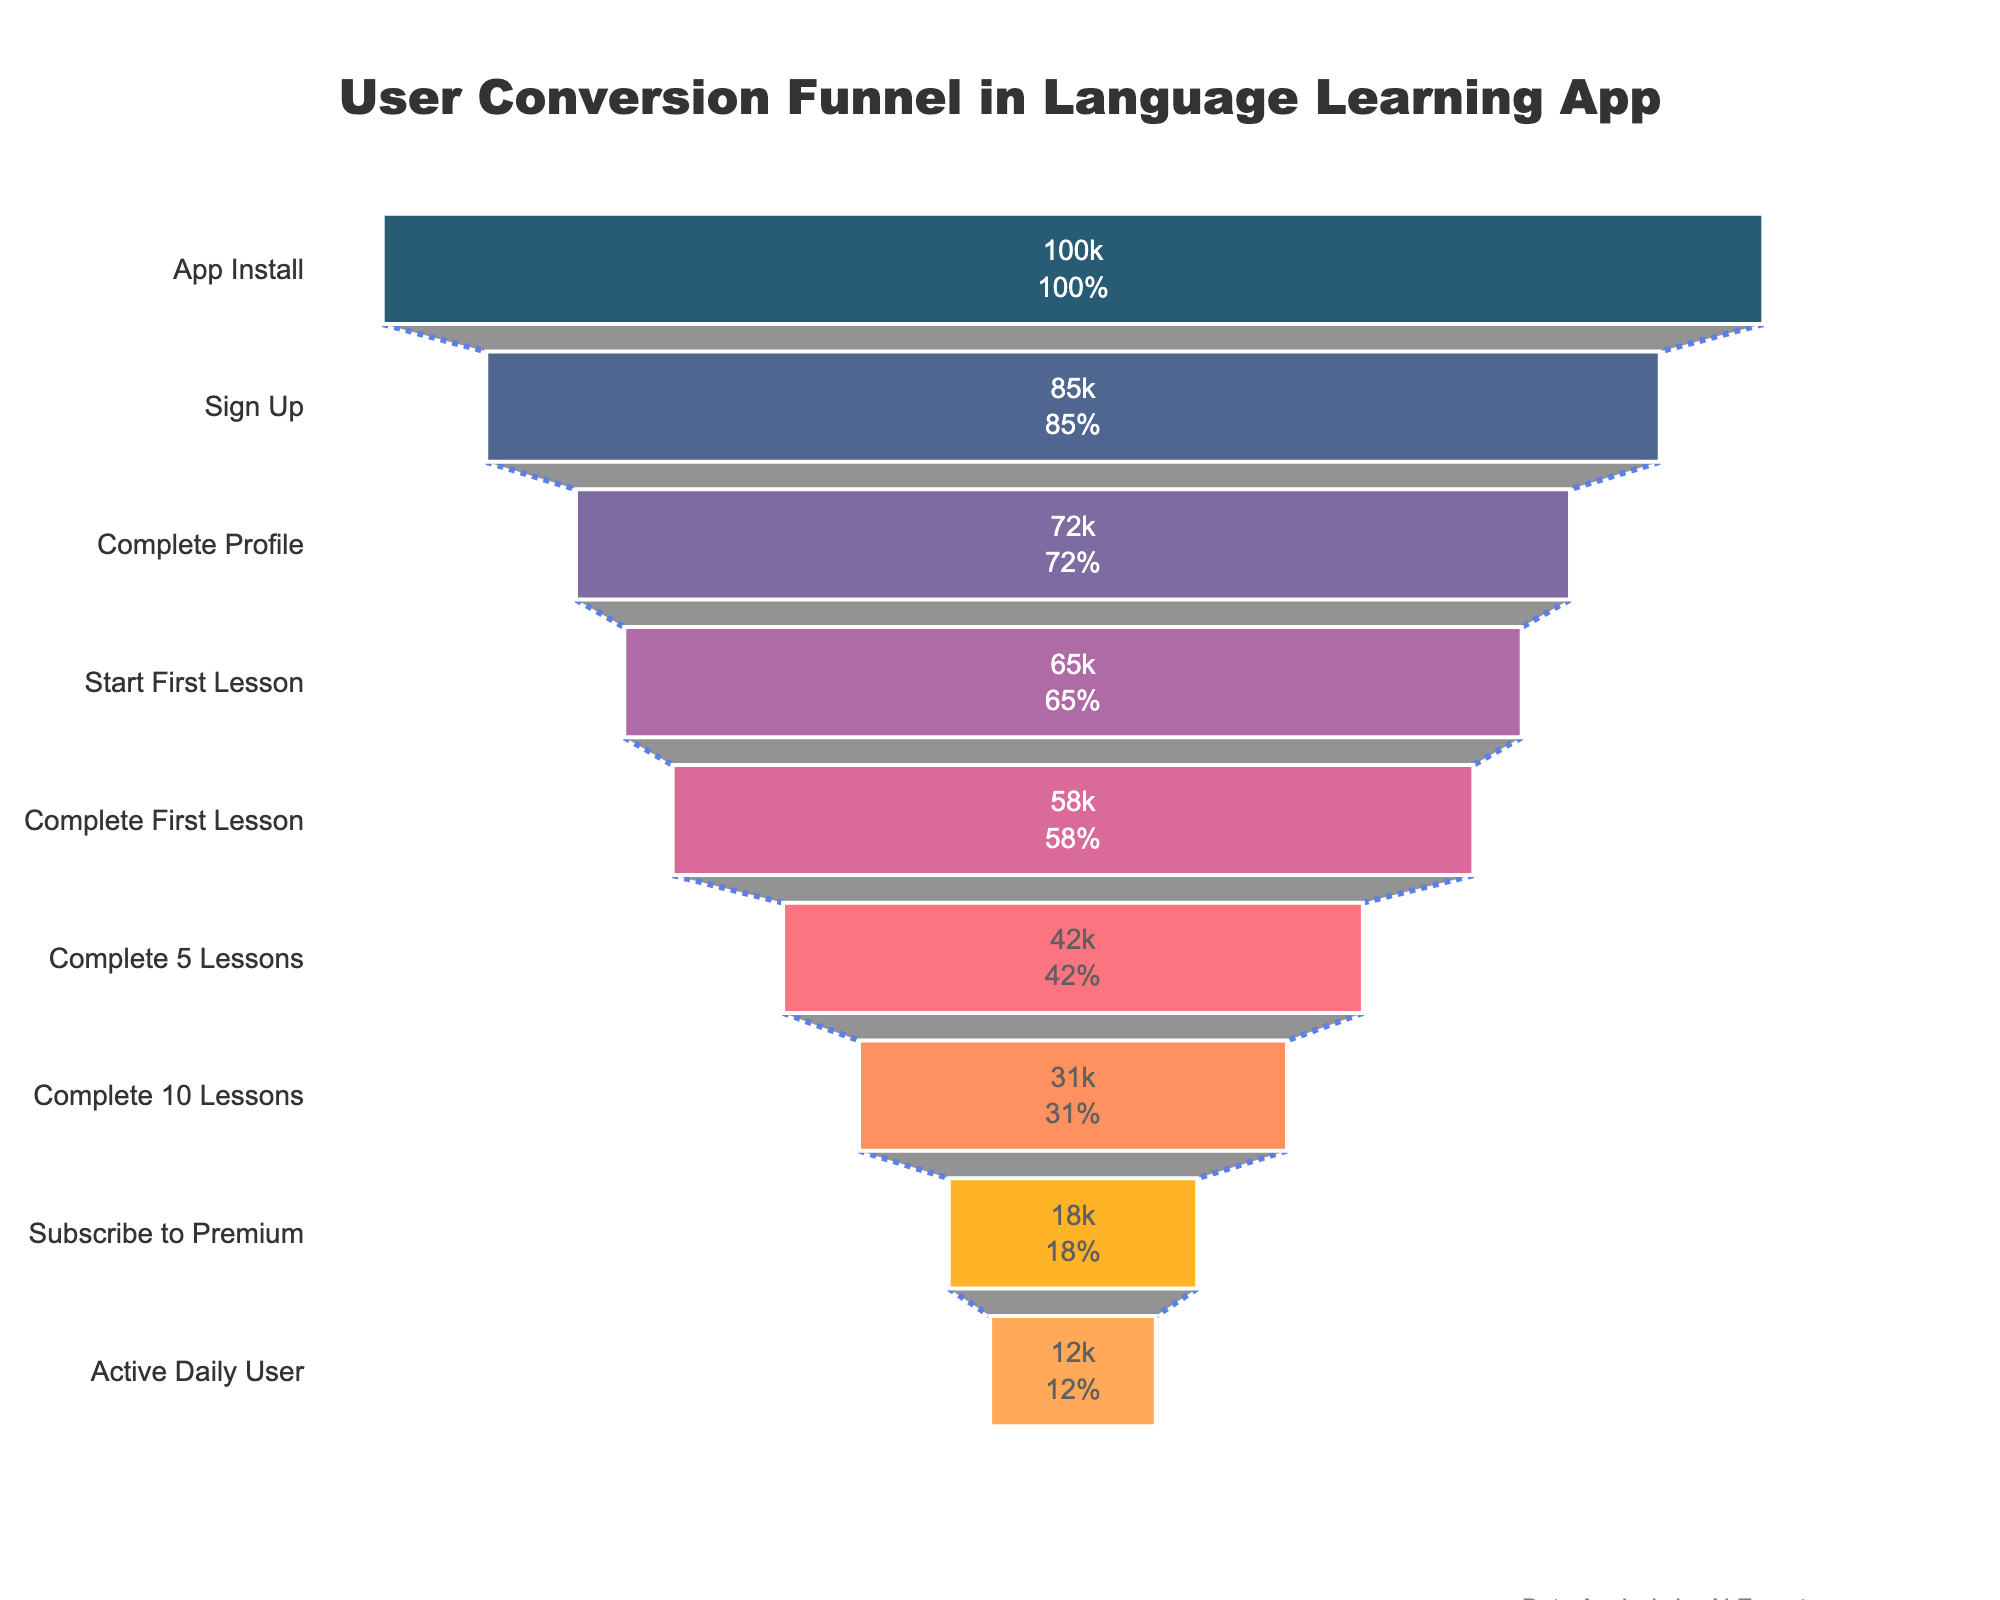How many stages are shown on the funnel chart? Count the number of distinct stages listed from top to bottom in the funnel.
Answer: 9 What is the title of the funnel chart? The title is usually displayed at the top center of the chart.
Answer: User Conversion Funnel in Language Learning App How many users complete their profile after signing up? Subtract the number of users who signed up from those who completed their profile: 85000 - 72000.
Answer: 13000 What percentage of users who start the first lesson go on to complete the first lesson? Divide the number of users who completed the first lesson by the number who started it, then multiply by 100: (58000 / 65000) * 100.
Answer: ~89.23% How many more users subscribe to premium compared to those who complete 10 lessons? Subtract the users who completed 10 lessons from those who subscribe to premium: 31000 - 18000.
Answer: 13000 Which stage has the largest drop in users compared to the previous stage? Find the stage with the largest difference in the number of users when moving from one stage to the next. The largest drop is from "Complete 5 Lessons" to "Complete 10 Lessons": 42000 - 31000.
Answer: 11000 What is the percentage of active daily users relative to the number of app installs? Divide the number of active daily users by the number of app installs, then multiply by 100: (12000 / 100000) * 100.
Answer: 12% Between which stages is the smallest percentage drop in users observed? Calculate the percentage reduction between each consecutive stage, then find the smallest percentage drop. The smallest drop is from "Complete Profile" to "Start First Lesson": (72000 - 65000) / 72000 * 100 = ~9.72%.
Answer: "Complete Profile" and "Start First Lesson" If the number of sign-ups increased by 10%, how many users would that equate to? Multiply the number of current sign-ups by 1.10: 85000 * 1.10.
Answer: 93500 Which stages have more than 50% user retention from the previous stage? Identify stages where the number of users doesn't reduce by more than half compared to the previous stage. The stages are "Complete Profile" (72000 from 85000) and "Complete First Lesson" (58000 from 65000).
Answer: "Complete Profile" and "Complete First Lesson" 